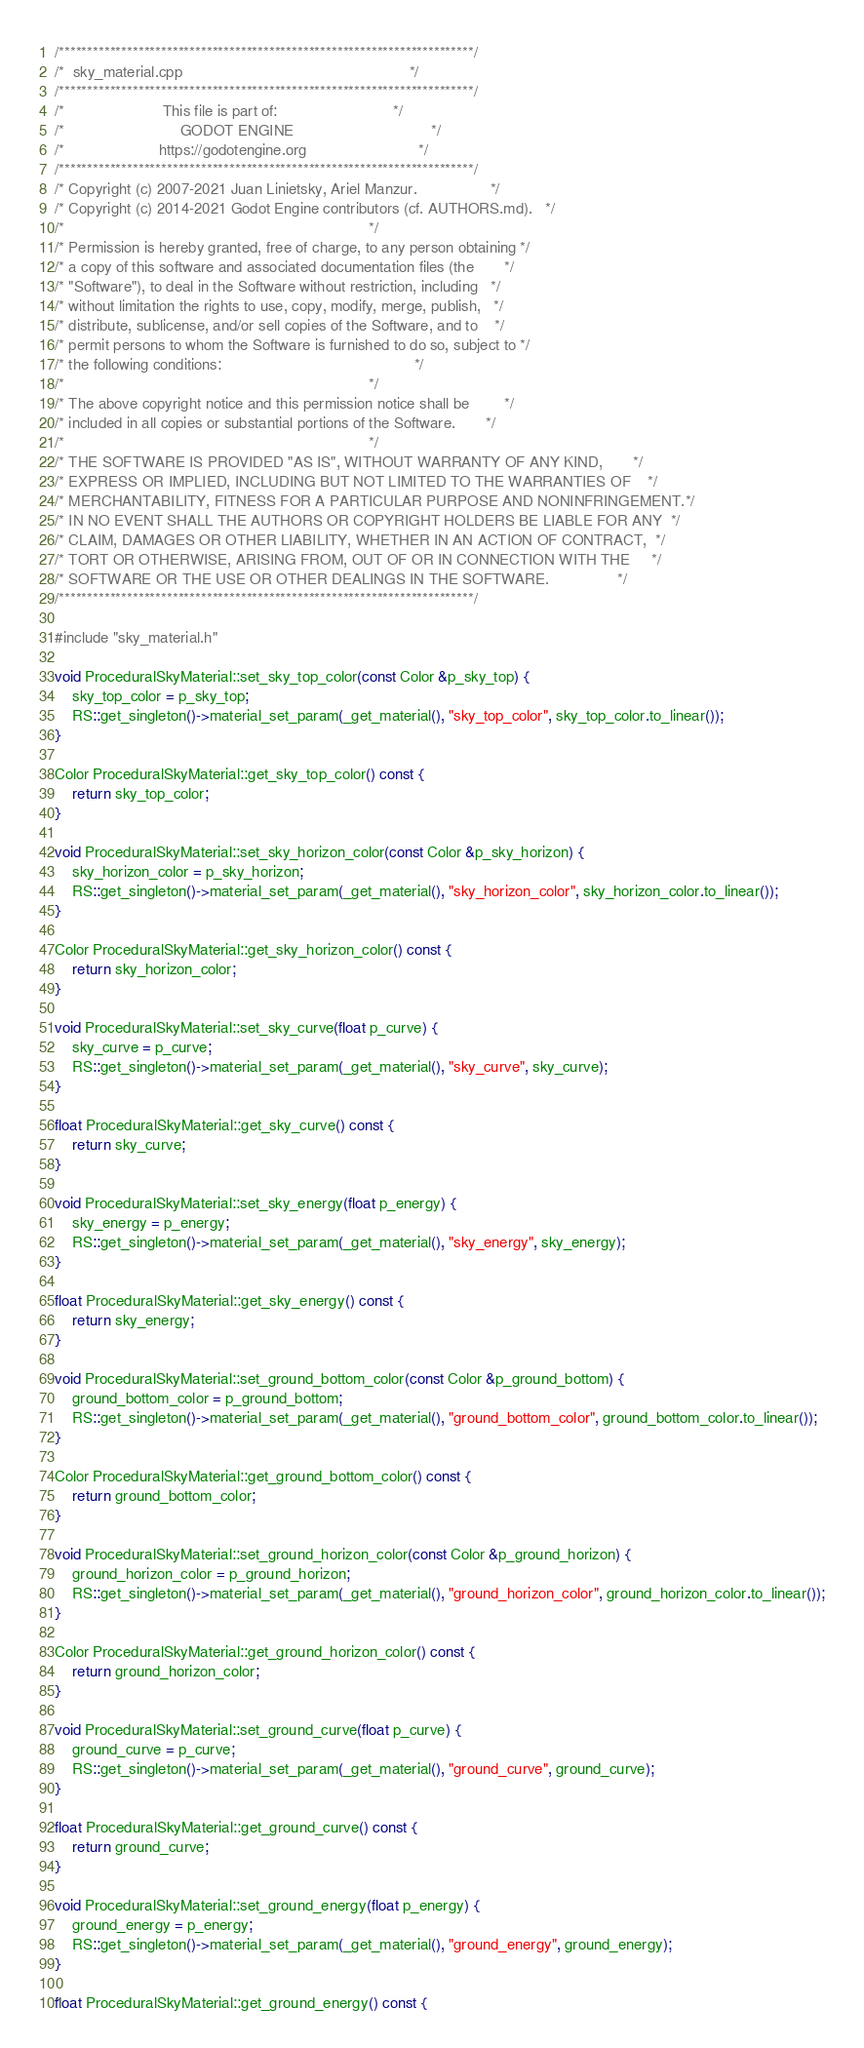<code> <loc_0><loc_0><loc_500><loc_500><_C++_>/*************************************************************************/
/*  sky_material.cpp                                                     */
/*************************************************************************/
/*                       This file is part of:                           */
/*                           GODOT ENGINE                                */
/*                      https://godotengine.org                          */
/*************************************************************************/
/* Copyright (c) 2007-2021 Juan Linietsky, Ariel Manzur.                 */
/* Copyright (c) 2014-2021 Godot Engine contributors (cf. AUTHORS.md).   */
/*                                                                       */
/* Permission is hereby granted, free of charge, to any person obtaining */
/* a copy of this software and associated documentation files (the       */
/* "Software"), to deal in the Software without restriction, including   */
/* without limitation the rights to use, copy, modify, merge, publish,   */
/* distribute, sublicense, and/or sell copies of the Software, and to    */
/* permit persons to whom the Software is furnished to do so, subject to */
/* the following conditions:                                             */
/*                                                                       */
/* The above copyright notice and this permission notice shall be        */
/* included in all copies or substantial portions of the Software.       */
/*                                                                       */
/* THE SOFTWARE IS PROVIDED "AS IS", WITHOUT WARRANTY OF ANY KIND,       */
/* EXPRESS OR IMPLIED, INCLUDING BUT NOT LIMITED TO THE WARRANTIES OF    */
/* MERCHANTABILITY, FITNESS FOR A PARTICULAR PURPOSE AND NONINFRINGEMENT.*/
/* IN NO EVENT SHALL THE AUTHORS OR COPYRIGHT HOLDERS BE LIABLE FOR ANY  */
/* CLAIM, DAMAGES OR OTHER LIABILITY, WHETHER IN AN ACTION OF CONTRACT,  */
/* TORT OR OTHERWISE, ARISING FROM, OUT OF OR IN CONNECTION WITH THE     */
/* SOFTWARE OR THE USE OR OTHER DEALINGS IN THE SOFTWARE.                */
/*************************************************************************/

#include "sky_material.h"

void ProceduralSkyMaterial::set_sky_top_color(const Color &p_sky_top) {
	sky_top_color = p_sky_top;
	RS::get_singleton()->material_set_param(_get_material(), "sky_top_color", sky_top_color.to_linear());
}

Color ProceduralSkyMaterial::get_sky_top_color() const {
	return sky_top_color;
}

void ProceduralSkyMaterial::set_sky_horizon_color(const Color &p_sky_horizon) {
	sky_horizon_color = p_sky_horizon;
	RS::get_singleton()->material_set_param(_get_material(), "sky_horizon_color", sky_horizon_color.to_linear());
}

Color ProceduralSkyMaterial::get_sky_horizon_color() const {
	return sky_horizon_color;
}

void ProceduralSkyMaterial::set_sky_curve(float p_curve) {
	sky_curve = p_curve;
	RS::get_singleton()->material_set_param(_get_material(), "sky_curve", sky_curve);
}

float ProceduralSkyMaterial::get_sky_curve() const {
	return sky_curve;
}

void ProceduralSkyMaterial::set_sky_energy(float p_energy) {
	sky_energy = p_energy;
	RS::get_singleton()->material_set_param(_get_material(), "sky_energy", sky_energy);
}

float ProceduralSkyMaterial::get_sky_energy() const {
	return sky_energy;
}

void ProceduralSkyMaterial::set_ground_bottom_color(const Color &p_ground_bottom) {
	ground_bottom_color = p_ground_bottom;
	RS::get_singleton()->material_set_param(_get_material(), "ground_bottom_color", ground_bottom_color.to_linear());
}

Color ProceduralSkyMaterial::get_ground_bottom_color() const {
	return ground_bottom_color;
}

void ProceduralSkyMaterial::set_ground_horizon_color(const Color &p_ground_horizon) {
	ground_horizon_color = p_ground_horizon;
	RS::get_singleton()->material_set_param(_get_material(), "ground_horizon_color", ground_horizon_color.to_linear());
}

Color ProceduralSkyMaterial::get_ground_horizon_color() const {
	return ground_horizon_color;
}

void ProceduralSkyMaterial::set_ground_curve(float p_curve) {
	ground_curve = p_curve;
	RS::get_singleton()->material_set_param(_get_material(), "ground_curve", ground_curve);
}

float ProceduralSkyMaterial::get_ground_curve() const {
	return ground_curve;
}

void ProceduralSkyMaterial::set_ground_energy(float p_energy) {
	ground_energy = p_energy;
	RS::get_singleton()->material_set_param(_get_material(), "ground_energy", ground_energy);
}

float ProceduralSkyMaterial::get_ground_energy() const {</code> 